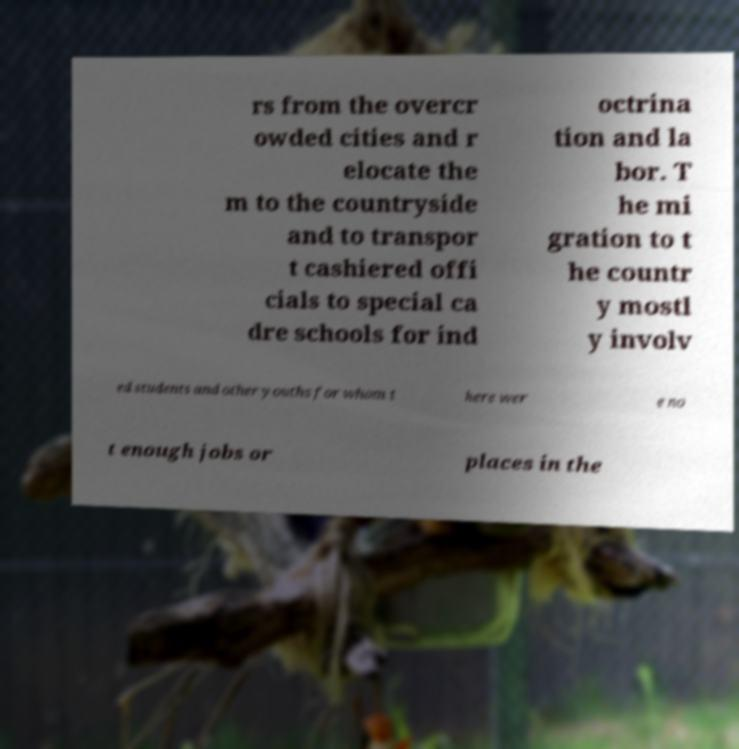Can you read and provide the text displayed in the image?This photo seems to have some interesting text. Can you extract and type it out for me? rs from the overcr owded cities and r elocate the m to the countryside and to transpor t cashiered offi cials to special ca dre schools for ind octrina tion and la bor. T he mi gration to t he countr y mostl y involv ed students and other youths for whom t here wer e no t enough jobs or places in the 